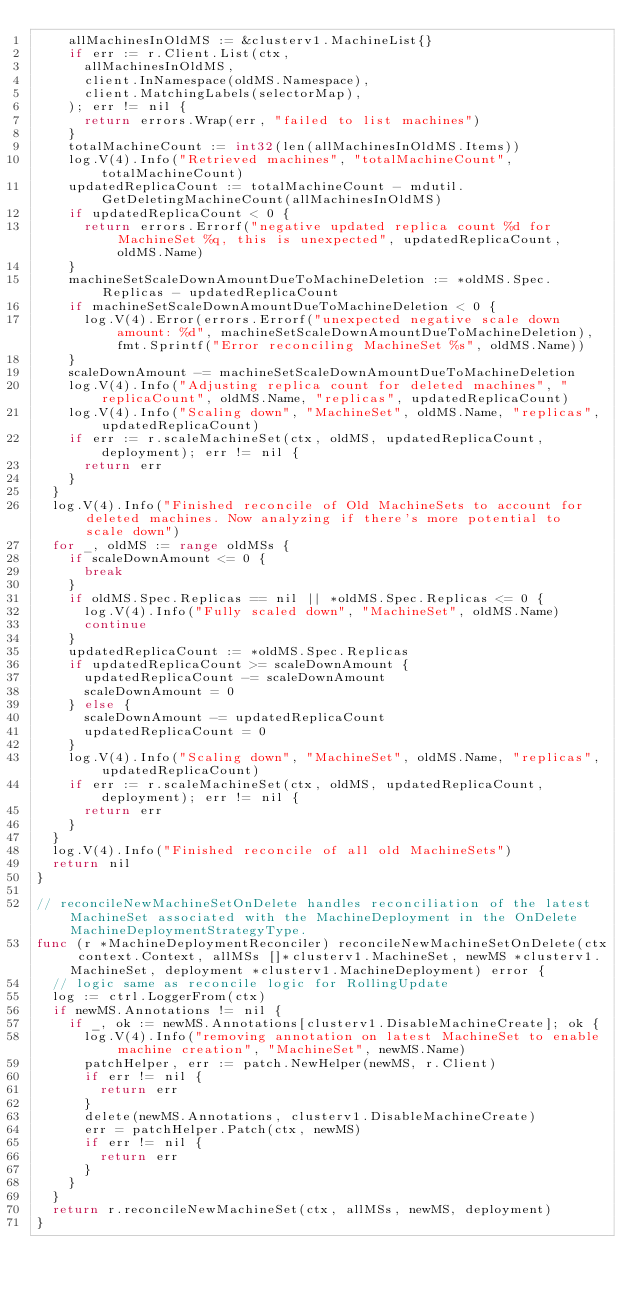Convert code to text. <code><loc_0><loc_0><loc_500><loc_500><_Go_>		allMachinesInOldMS := &clusterv1.MachineList{}
		if err := r.Client.List(ctx,
			allMachinesInOldMS,
			client.InNamespace(oldMS.Namespace),
			client.MatchingLabels(selectorMap),
		); err != nil {
			return errors.Wrap(err, "failed to list machines")
		}
		totalMachineCount := int32(len(allMachinesInOldMS.Items))
		log.V(4).Info("Retrieved machines", "totalMachineCount", totalMachineCount)
		updatedReplicaCount := totalMachineCount - mdutil.GetDeletingMachineCount(allMachinesInOldMS)
		if updatedReplicaCount < 0 {
			return errors.Errorf("negative updated replica count %d for MachineSet %q, this is unexpected", updatedReplicaCount, oldMS.Name)
		}
		machineSetScaleDownAmountDueToMachineDeletion := *oldMS.Spec.Replicas - updatedReplicaCount
		if machineSetScaleDownAmountDueToMachineDeletion < 0 {
			log.V(4).Error(errors.Errorf("unexpected negative scale down amount: %d", machineSetScaleDownAmountDueToMachineDeletion), fmt.Sprintf("Error reconciling MachineSet %s", oldMS.Name))
		}
		scaleDownAmount -= machineSetScaleDownAmountDueToMachineDeletion
		log.V(4).Info("Adjusting replica count for deleted machines", "replicaCount", oldMS.Name, "replicas", updatedReplicaCount)
		log.V(4).Info("Scaling down", "MachineSet", oldMS.Name, "replicas", updatedReplicaCount)
		if err := r.scaleMachineSet(ctx, oldMS, updatedReplicaCount, deployment); err != nil {
			return err
		}
	}
	log.V(4).Info("Finished reconcile of Old MachineSets to account for deleted machines. Now analyzing if there's more potential to scale down")
	for _, oldMS := range oldMSs {
		if scaleDownAmount <= 0 {
			break
		}
		if oldMS.Spec.Replicas == nil || *oldMS.Spec.Replicas <= 0 {
			log.V(4).Info("Fully scaled down", "MachineSet", oldMS.Name)
			continue
		}
		updatedReplicaCount := *oldMS.Spec.Replicas
		if updatedReplicaCount >= scaleDownAmount {
			updatedReplicaCount -= scaleDownAmount
			scaleDownAmount = 0
		} else {
			scaleDownAmount -= updatedReplicaCount
			updatedReplicaCount = 0
		}
		log.V(4).Info("Scaling down", "MachineSet", oldMS.Name, "replicas", updatedReplicaCount)
		if err := r.scaleMachineSet(ctx, oldMS, updatedReplicaCount, deployment); err != nil {
			return err
		}
	}
	log.V(4).Info("Finished reconcile of all old MachineSets")
	return nil
}

// reconcileNewMachineSetOnDelete handles reconciliation of the latest MachineSet associated with the MachineDeployment in the OnDelete MachineDeploymentStrategyType.
func (r *MachineDeploymentReconciler) reconcileNewMachineSetOnDelete(ctx context.Context, allMSs []*clusterv1.MachineSet, newMS *clusterv1.MachineSet, deployment *clusterv1.MachineDeployment) error {
	// logic same as reconcile logic for RollingUpdate
	log := ctrl.LoggerFrom(ctx)
	if newMS.Annotations != nil {
		if _, ok := newMS.Annotations[clusterv1.DisableMachineCreate]; ok {
			log.V(4).Info("removing annotation on latest MachineSet to enable machine creation", "MachineSet", newMS.Name)
			patchHelper, err := patch.NewHelper(newMS, r.Client)
			if err != nil {
				return err
			}
			delete(newMS.Annotations, clusterv1.DisableMachineCreate)
			err = patchHelper.Patch(ctx, newMS)
			if err != nil {
				return err
			}
		}
	}
	return r.reconcileNewMachineSet(ctx, allMSs, newMS, deployment)
}
</code> 